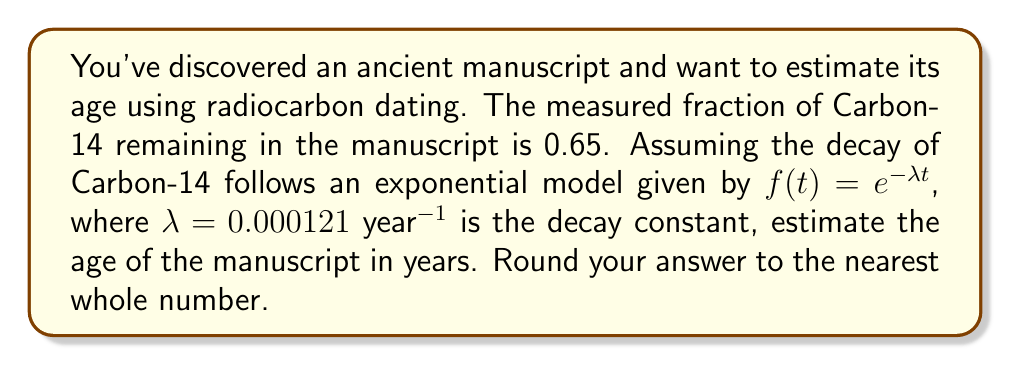What is the answer to this math problem? To solve this problem, we'll use the exponential decay model and the given information:

1) The exponential decay model is given by:
   $f(t) = e^{-\lambda t}$

2) We know:
   - $f(t) = 0.65$ (the fraction of Carbon-14 remaining)
   - $\lambda = 0.000121$ year$^{-1}$ (the decay constant)

3) Substituting these values into the equation:
   $0.65 = e^{-0.000121t}$

4) To solve for $t$, we need to take the natural logarithm of both sides:
   $\ln(0.65) = \ln(e^{-0.000121t})$

5) Using the properties of logarithms:
   $\ln(0.65) = -0.000121t$

6) Now we can solve for $t$:
   $t = \frac{\ln(0.65)}{-0.000121}$

7) Calculate the value:
   $t = \frac{-0.4308}{-0.000121} \approx 3560.33$ years

8) Rounding to the nearest whole number:
   $t \approx 3560$ years
Answer: 3560 years 